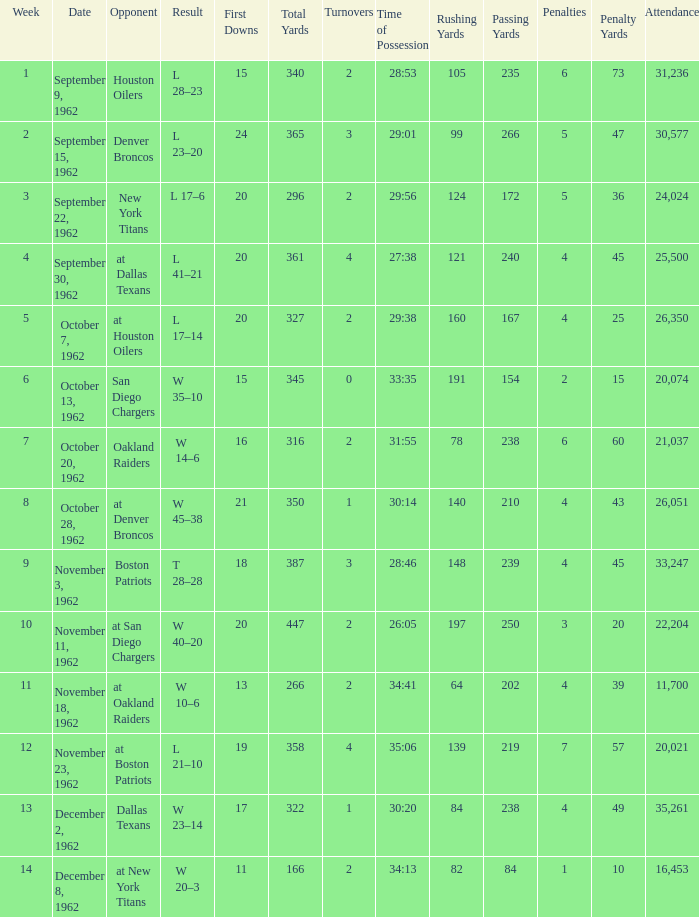What week was the attendance smaller than 22,204 on December 8, 1962? 14.0. 